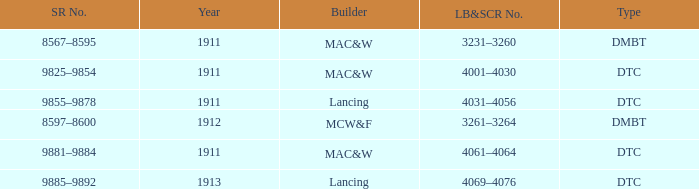Name the LB&SCR number that has SR number of 8597–8600 3261–3264. 